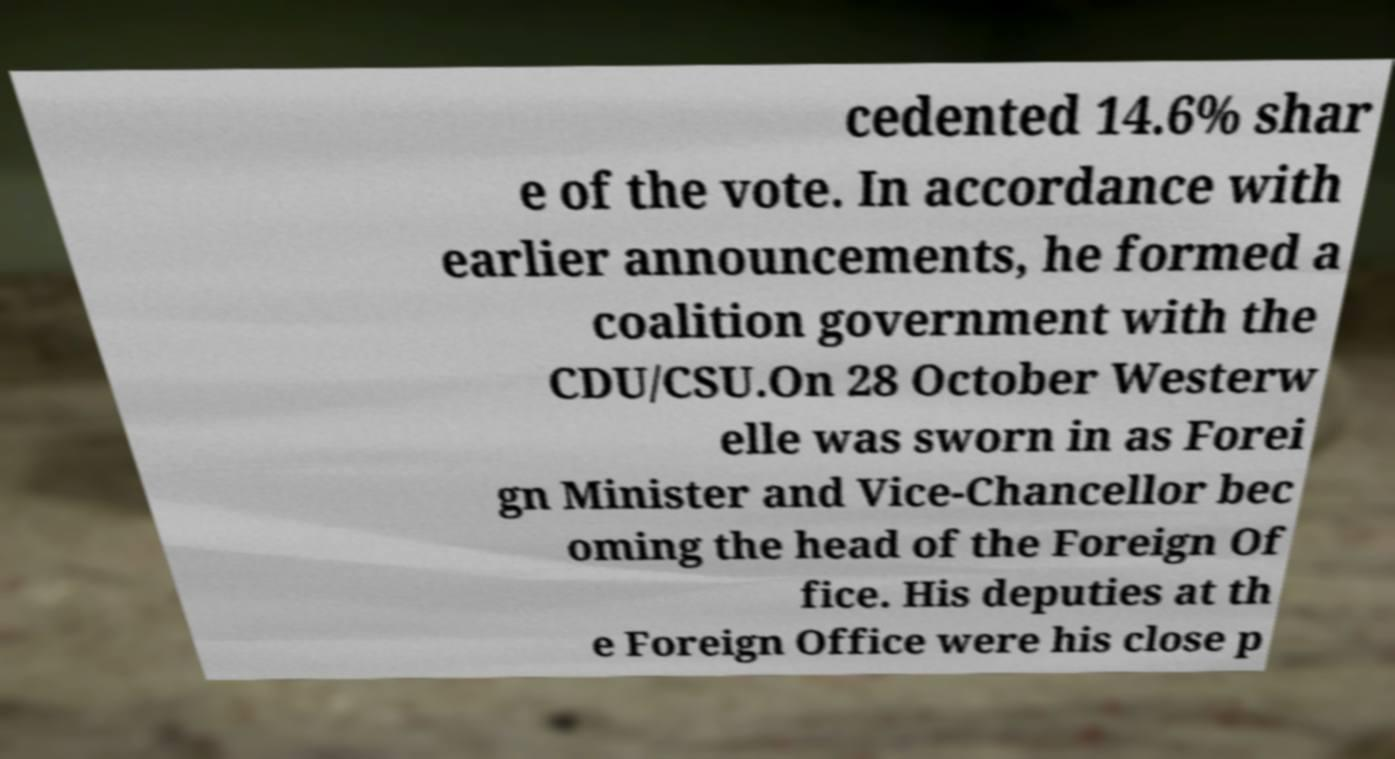There's text embedded in this image that I need extracted. Can you transcribe it verbatim? cedented 14.6% shar e of the vote. In accordance with earlier announcements, he formed a coalition government with the CDU/CSU.On 28 October Westerw elle was sworn in as Forei gn Minister and Vice-Chancellor bec oming the head of the Foreign Of fice. His deputies at th e Foreign Office were his close p 